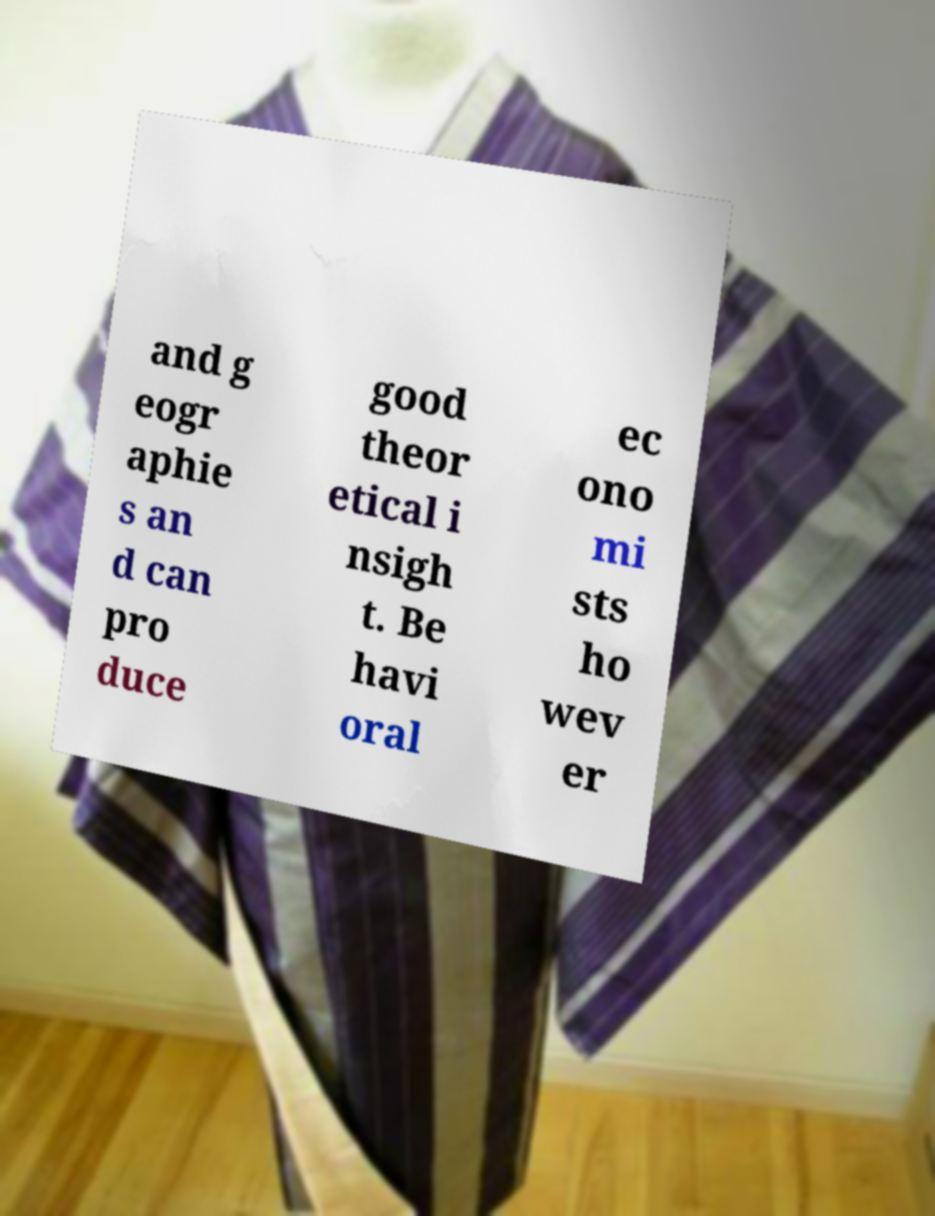What messages or text are displayed in this image? I need them in a readable, typed format. and g eogr aphie s an d can pro duce good theor etical i nsigh t. Be havi oral ec ono mi sts ho wev er 